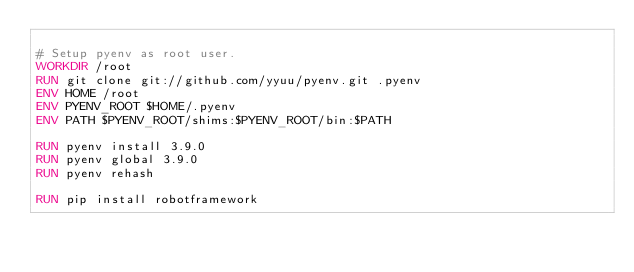<code> <loc_0><loc_0><loc_500><loc_500><_Dockerfile_>
# Setup pyenv as root user.
WORKDIR /root
RUN git clone git://github.com/yyuu/pyenv.git .pyenv
ENV HOME /root
ENV PYENV_ROOT $HOME/.pyenv
ENV PATH $PYENV_ROOT/shims:$PYENV_ROOT/bin:$PATH

RUN pyenv install 3.9.0
RUN pyenv global 3.9.0
RUN pyenv rehash

RUN pip install robotframework

</code> 